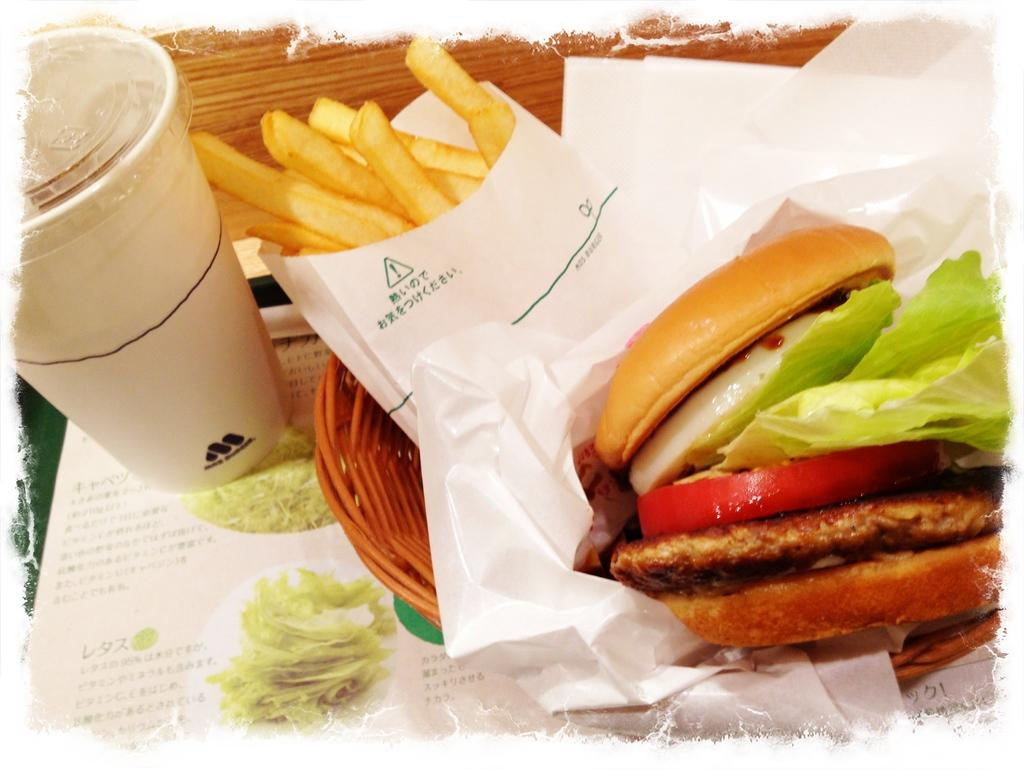What type of food can be seen in the image? There is a burger and french fries in the image. What is the glass on the table likely to contain? The glass on the table is likely to contain a beverage. What is the food item in the basket? The food item in the basket is not specified, but it is likely to be another type of food. How does the queen stretch her thread in the image? There is no queen or thread present in the image; it features a burger, french fries, a glass, and a food item in a basket. 